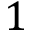Convert formula to latex. <formula><loc_0><loc_0><loc_500><loc_500>1</formula> 